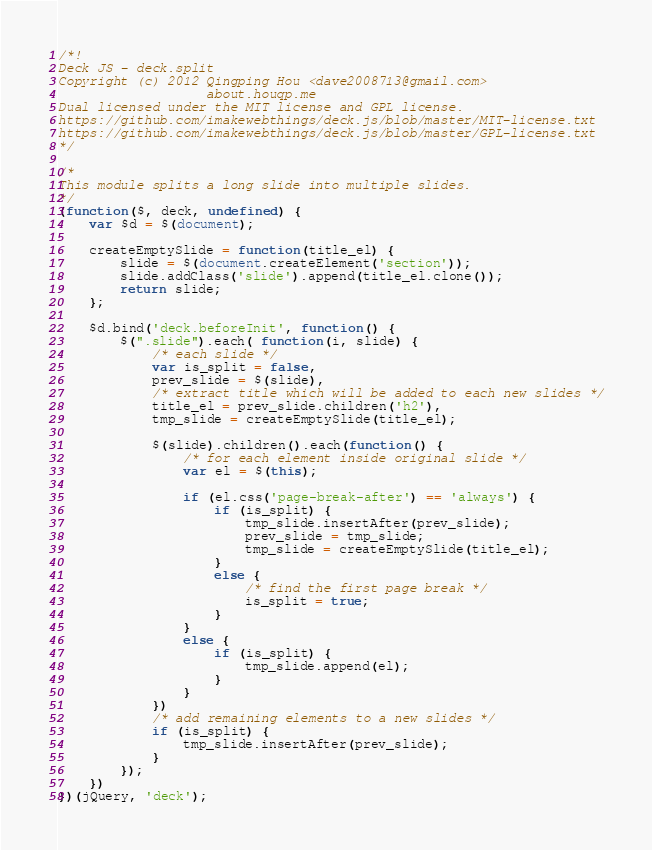<code> <loc_0><loc_0><loc_500><loc_500><_JavaScript_>/*!
Deck JS - deck.split
Copyright (c) 2012 Qingping Hou <dave2008713@gmail.com>
                   about.houqp.me
Dual licensed under the MIT license and GPL license.
https://github.com/imakewebthings/deck.js/blob/master/MIT-license.txt
https://github.com/imakewebthings/deck.js/blob/master/GPL-license.txt
*/

/*
This module splits a long slide into multiple slides.
*/
(function($, deck, undefined) {
	var $d = $(document);

	createEmptySlide = function(title_el) {
		slide = $(document.createElement('section'));
		slide.addClass('slide').append(title_el.clone());
		return slide;
	};

	$d.bind('deck.beforeInit', function() {
		$(".slide").each( function(i, slide) {
			/* each slide */
			var is_split = false,
			prev_slide = $(slide),
			/* extract title which will be added to each new slides */
			title_el = prev_slide.children('h2'),
			tmp_slide = createEmptySlide(title_el);

			$(slide).children().each(function() {
				/* for each element inside original slide */
				var el = $(this);

				if (el.css('page-break-after') == 'always') {
					if (is_split) {
						tmp_slide.insertAfter(prev_slide);
						prev_slide = tmp_slide;
						tmp_slide = createEmptySlide(title_el);
					}
					else {
						/* find the first page break */
						is_split = true;
					}
				}
				else {
					if (is_split) {
						tmp_slide.append(el);
					}
				}
			})
			/* add remaining elements to a new slides */
			if (is_split) {
				tmp_slide.insertAfter(prev_slide);
			}
		});
	})
})(jQuery, 'deck');

</code> 